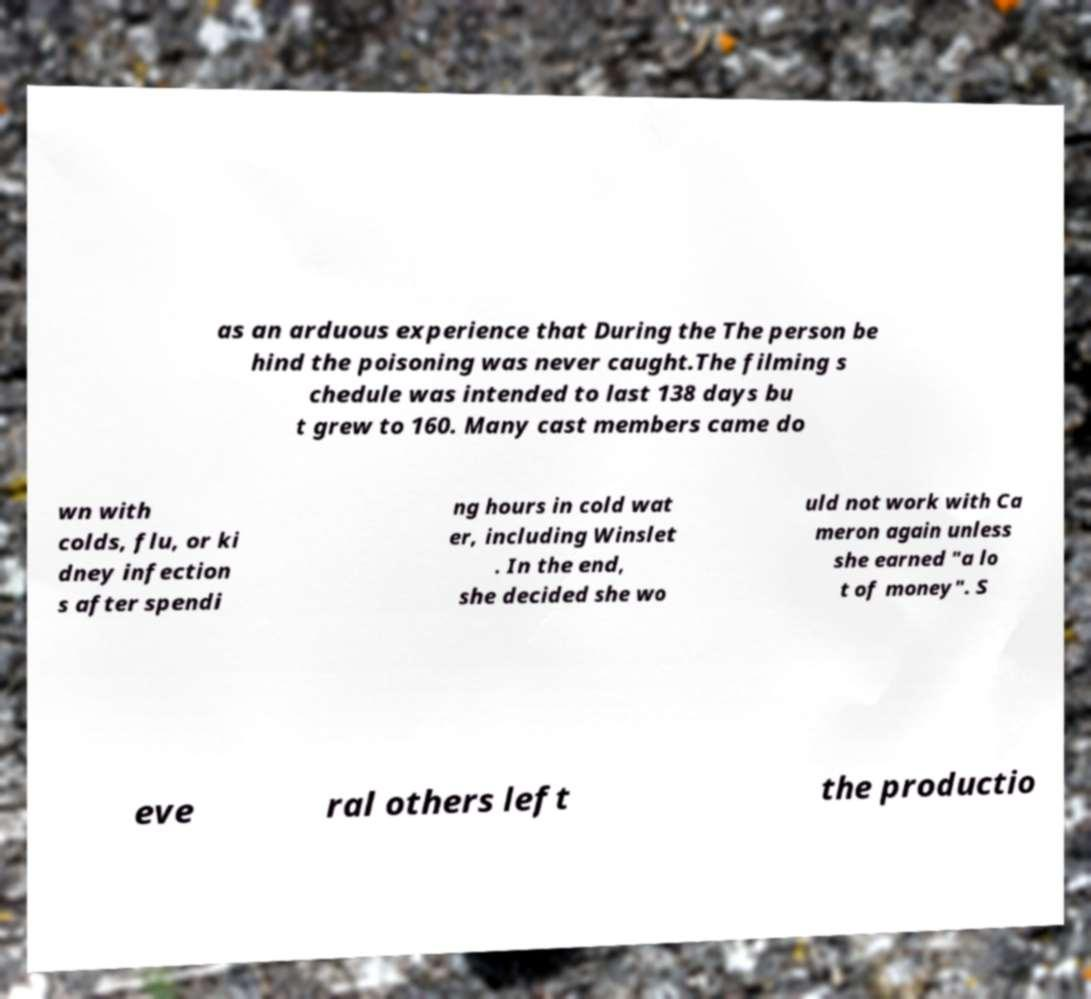I need the written content from this picture converted into text. Can you do that? as an arduous experience that During the The person be hind the poisoning was never caught.The filming s chedule was intended to last 138 days bu t grew to 160. Many cast members came do wn with colds, flu, or ki dney infection s after spendi ng hours in cold wat er, including Winslet . In the end, she decided she wo uld not work with Ca meron again unless she earned "a lo t of money". S eve ral others left the productio 